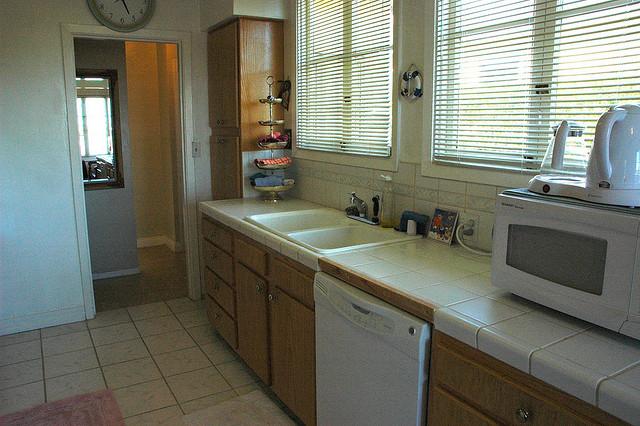Is there a dishwasher in this kitchen?
Write a very short answer. Yes. What is on top of the microwave?
Short answer required. Coffee pot. Could the clock be about 4:50 AM?
Give a very brief answer. Yes. 